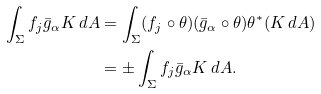<formula> <loc_0><loc_0><loc_500><loc_500>\int _ { \Sigma } f _ { j } \bar { g } _ { \alpha } K \, d A & = \int _ { \Sigma } ( f _ { j } \circ \theta ) ( \bar { g } _ { \alpha } \circ \theta ) \theta ^ { * } ( K \, d A ) \\ & = \pm \int _ { \Sigma } f _ { j } \bar { g } _ { \alpha } K \, d A .</formula> 